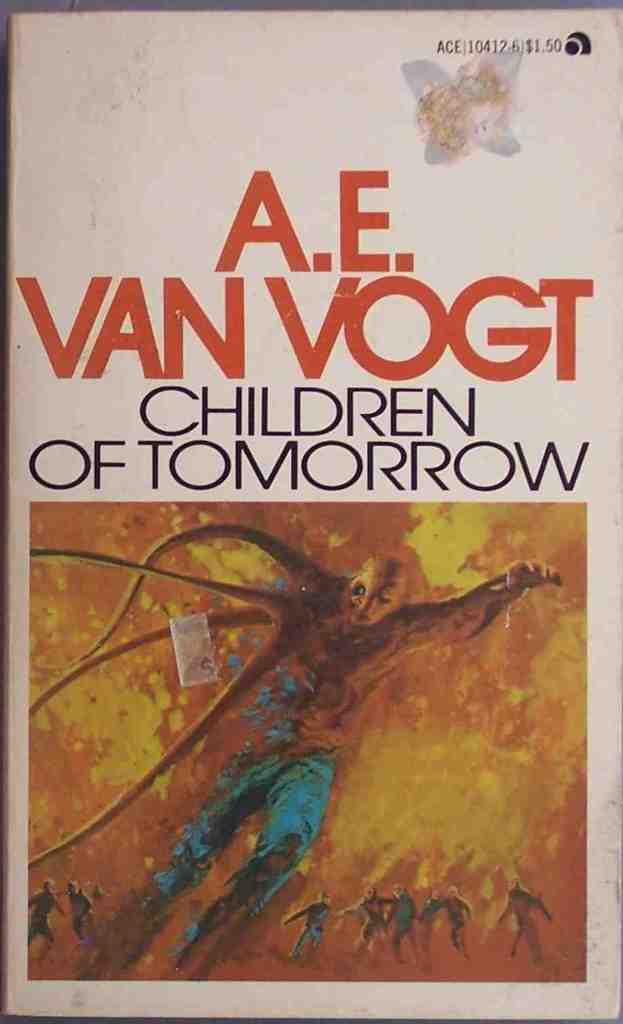<image>
Summarize the visual content of the image. A book by A.E. Van Vogt called Children of tomorrow. 